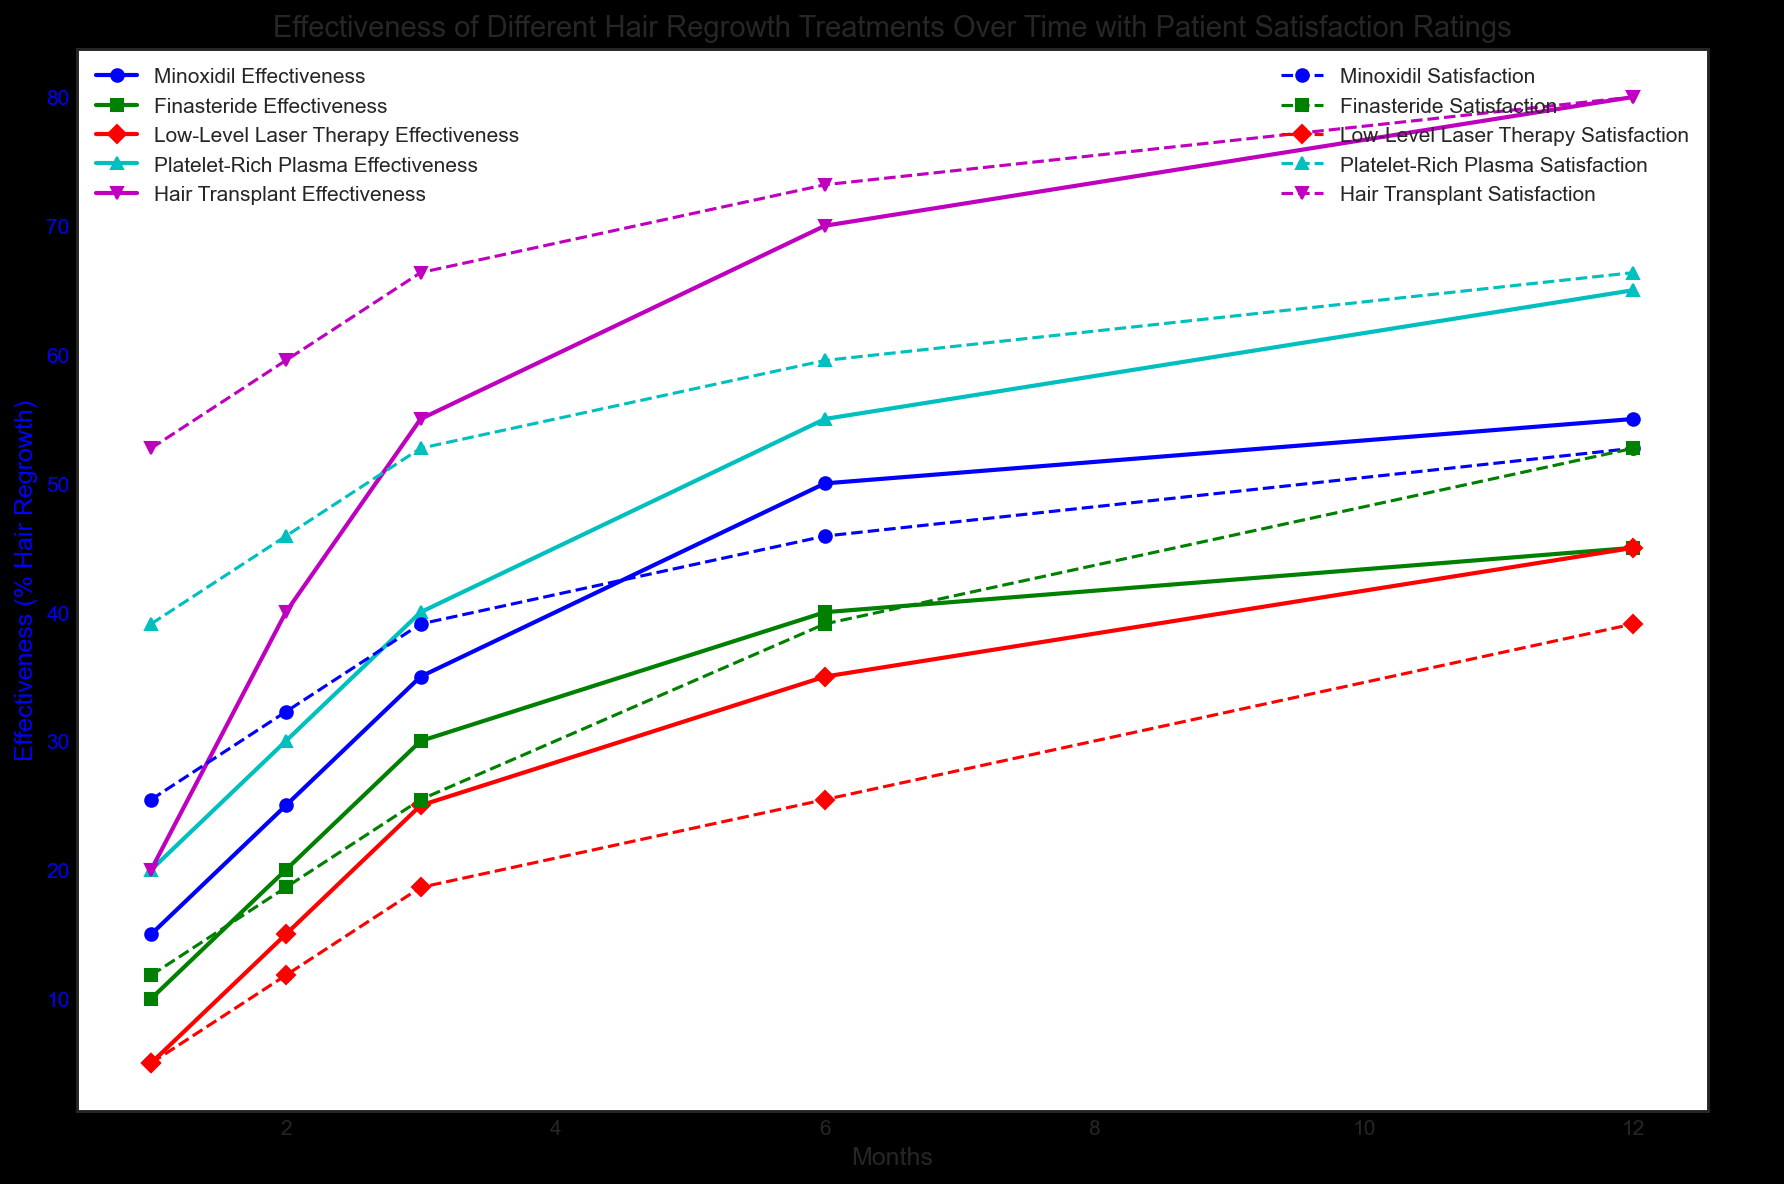What treatment shows the highest patient satisfaction at the 12-month mark? Looking at the secondary axis, the highest satisfaction rating at the 12-month mark is for Hair Transplant, which is 10.
Answer: Hair Transplant Among all treatments, which one showed the most significant improvement in hair regrowth effectiveness between the first and the twelfth month? By comparing the differences in effectiveness, Hair Transplant shows the most significant improvement, increasing from 20% to 80%, which is a 60% increase.
Answer: Hair Transplant For Platelet-Rich Plasma, what is the patient's satisfaction improvement from month 1 to month 6? The satisfaction rating for Platelet-Rich Plasma in month 1 is 7, and in month 6 is 8.5. The improvement is 8.5 - 7 = 1.5.
Answer: 1.5 Which treatment had the lowest effectiveness in the first month? By referring to the effectiveness on the primary axis at month 1, Low-Level Laser Therapy had the lowest effectiveness at 5%.
Answer: Low-Level Laser Therapy How does the effectiveness of Finasteride at month 6 compare with Minoxidil at month 3? Finasteride at month 6 has an effectiveness of 40%, whereas Minoxidil at month 3 has an effectiveness of 35%. Therefore, Finasteride at month 6 is more effective by 5%.
Answer: Finasteride at month 6 is 5% more effective What is the trend for patient satisfaction for Low-Level Laser Therapy over the 12 months? Patient satisfaction for Low-Level Laser Therapy increases consistently from 4.5 at month 1 to 7 at month 12, showing a positive trend.
Answer: Positive trend Between Minoxidil and Finasteride, which treatment's effectiveness grows faster in the first 3 months? Minoxidil's effectiveness grows from 15% to 35%, an increase of 20%. Finasteride grows from 10% to 30%, also an increase of 20%. Both treatments show equal growth in effectiveness over the first 3 months.
Answer: Equal growth Which treatment showed a consistent increase in both effectiveness and patient satisfaction over the entire period? Examining both effectiveness and patient satisfaction over time, every treatment displays consistent increases but Hair Transplant has a distinctive steady growth in both parameters.
Answer: Hair Transplant What is the average patient satisfaction for Minoxidil across the 12 months? Minoxidil’s satisfaction ratings over 12 months are 6, 6.5, 7, 7.5, and 8. The average is (6 + 6.5 + 7 + 7.5 + 8) / 5 = 7.0.
Answer: 7.0 How much more effective is Hair Transplant compared to Low-Level Laser Therapy at the 3-month mark? Hair Transplant's effectiveness at 3 months is 55%, while Low-Level Laser Therapy is at 25%. The difference is 55% - 25% = 30%.
Answer: 30% 